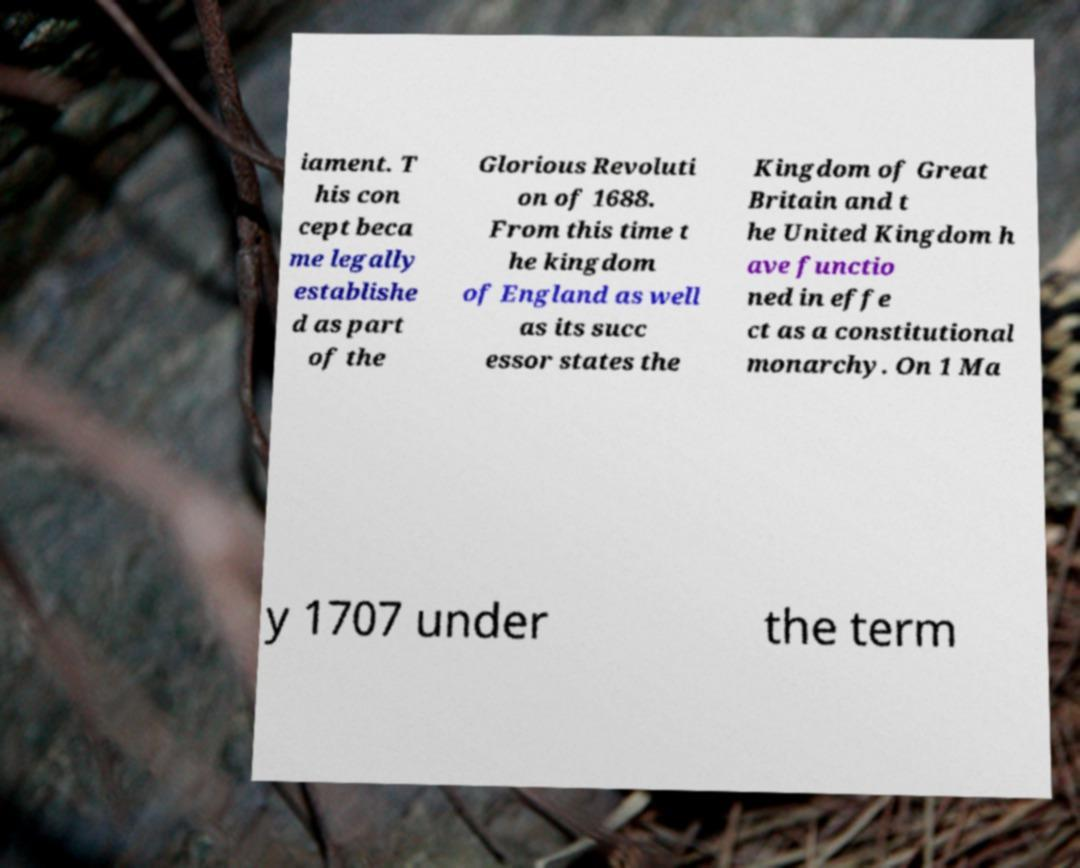Please identify and transcribe the text found in this image. iament. T his con cept beca me legally establishe d as part of the Glorious Revoluti on of 1688. From this time t he kingdom of England as well as its succ essor states the Kingdom of Great Britain and t he United Kingdom h ave functio ned in effe ct as a constitutional monarchy. On 1 Ma y 1707 under the term 